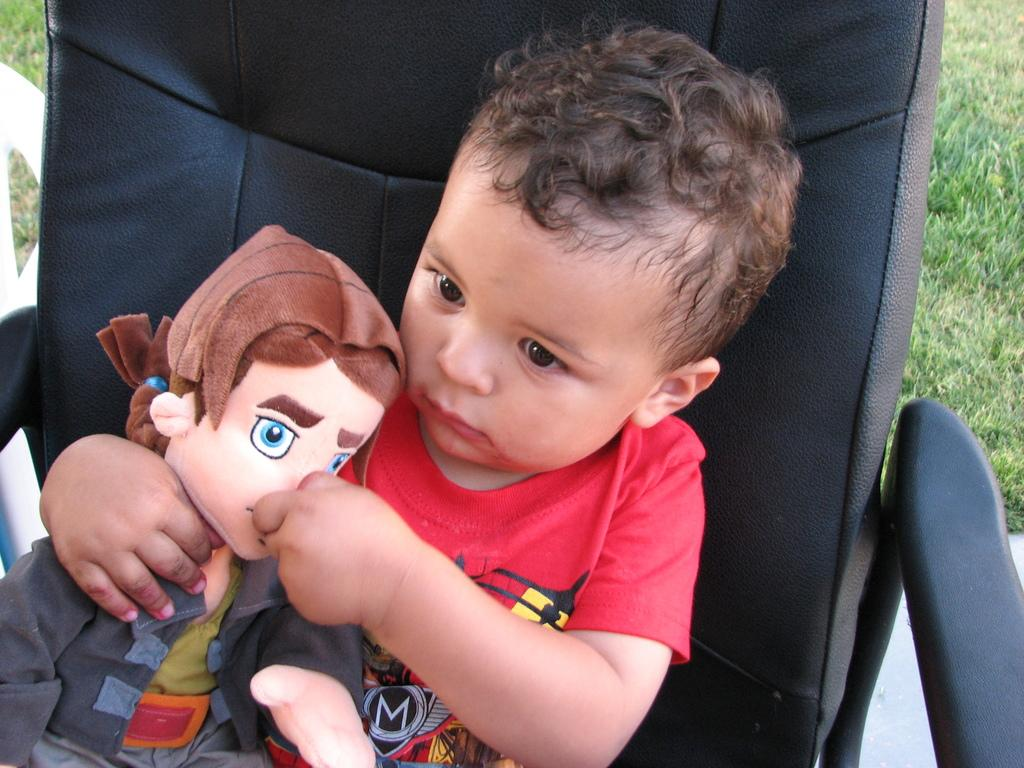What is the main subject of the image? There is a child in the image. What is the child doing in the image? The child is sitting on a chair. What is the child wearing in the image? The child is wearing a red dress. What is the child holding in the image? The child is holding a toy. What can be seen in the background of the image? There is grass visible in the background of the image. What degree does the child have in the image? There is no mention of a degree in the image, as it features a child sitting on a chair and holding a toy. 